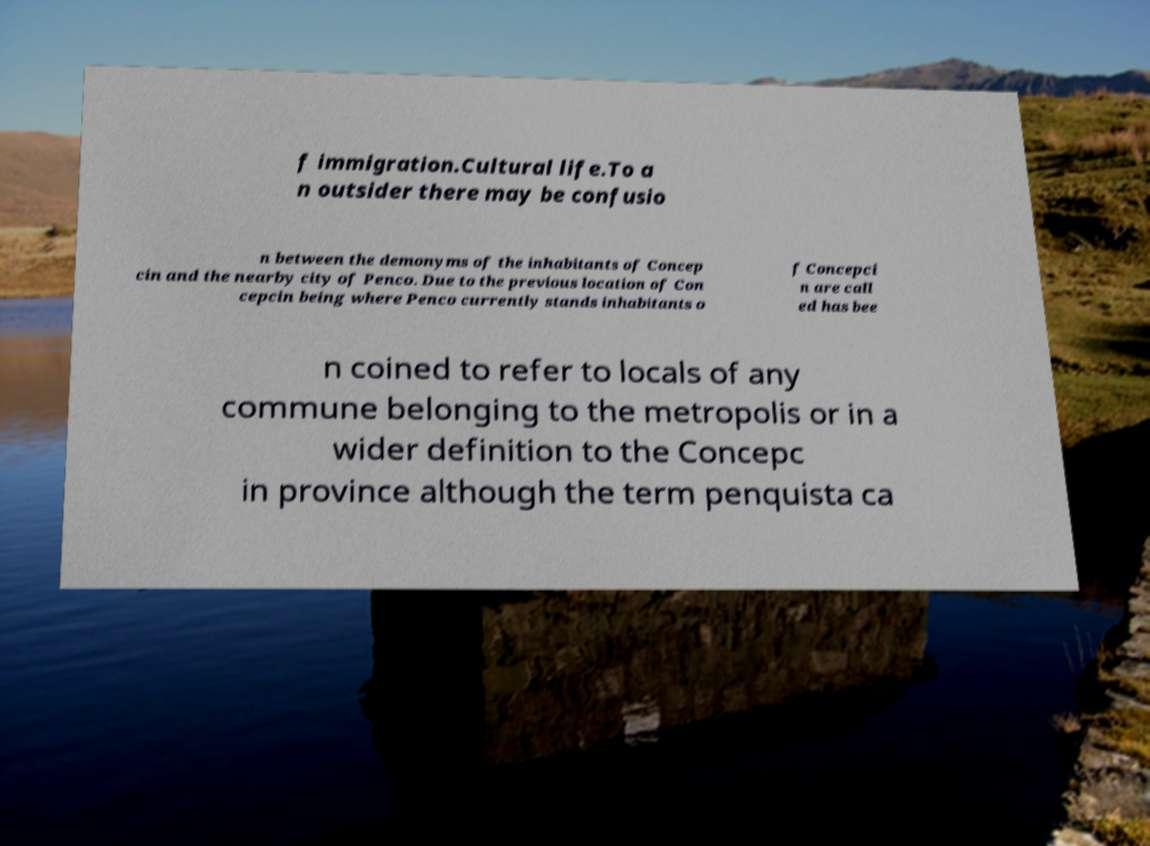Could you assist in decoding the text presented in this image and type it out clearly? f immigration.Cultural life.To a n outsider there may be confusio n between the demonyms of the inhabitants of Concep cin and the nearby city of Penco. Due to the previous location of Con cepcin being where Penco currently stands inhabitants o f Concepci n are call ed has bee n coined to refer to locals of any commune belonging to the metropolis or in a wider definition to the Concepc in province although the term penquista ca 